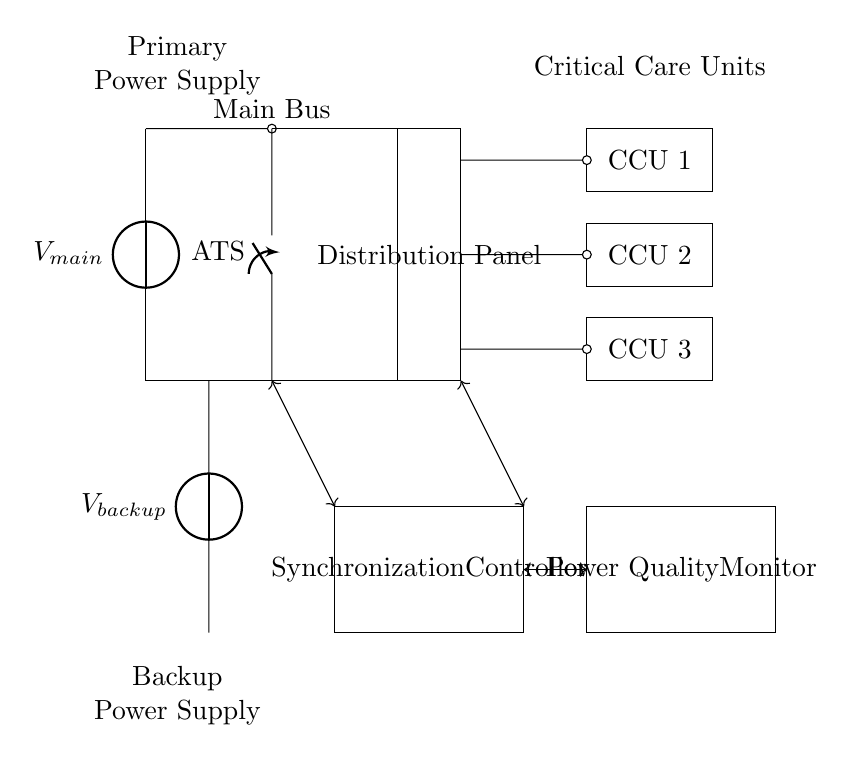What is the primary power source? The circuit diagram indicates that the primary power source is labeled as V_main, which is the main voltage source supplying power to the critical care units.
Answer: V_main What does ATS stand for? ATS in the circuit is labeled as the Automatic Transfer Switch, which switches the power supply between the main and backup sources to ensure continuous power delivery.
Answer: Automatic Transfer Switch How many critical care units are depicted? The diagram shows three rectangles labeled as CCU 1, CCU 2, and CCU 3, indicating there are three critical care units connected to the distribution panel.
Answer: Three What is the role of the Synchronization Controller? The Synchronization Controller is responsible for managing the synchronization between the main and backup power sources to ensure seamless operation during transfer.
Answer: Managing synchronization Which component monitors power quality? The Power Quality Monitor is explicitly labeled in the circuit and is designed to track and report on the quality of the power being distributed to the CCUs.
Answer: Power Quality Monitor What connects the main power source to the distribution panel? The main power source connects to the distribution panel via a short, as indicated by the line drawn between the two components in the circuit diagram.
Answer: A short What type of diagram is this? The arrangement of components including power sources, switches, and controllers, designed for critical care units indicates this is a synchronous power distribution network diagram.
Answer: Synchronous power distribution network 